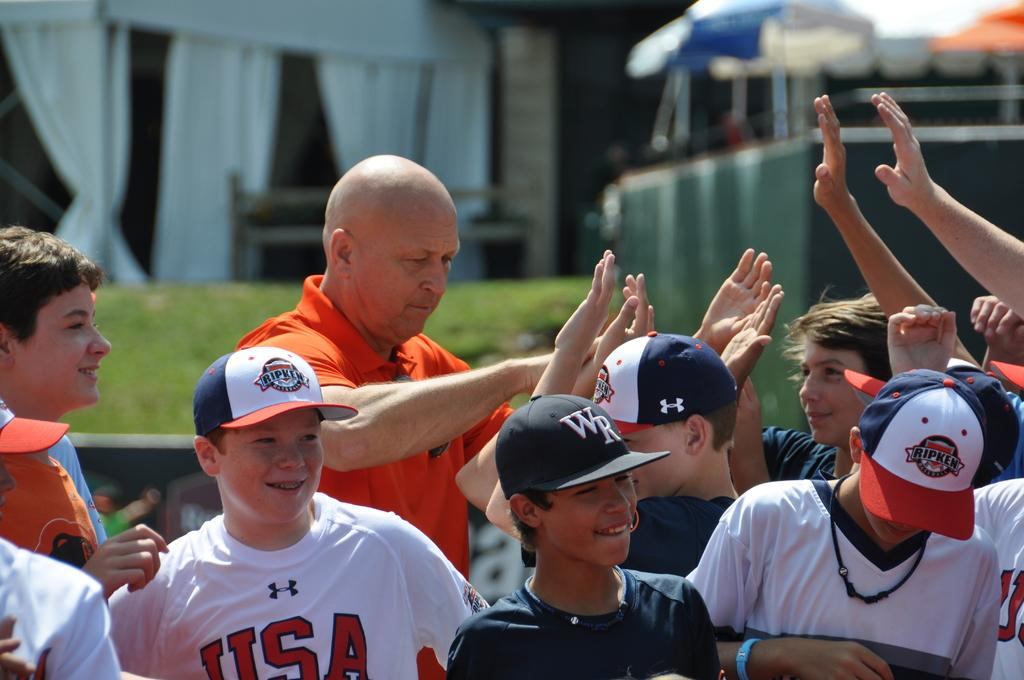Provide a one-sentence caption for the provided image. One of the children is wearing a white shirt with USA on it. 